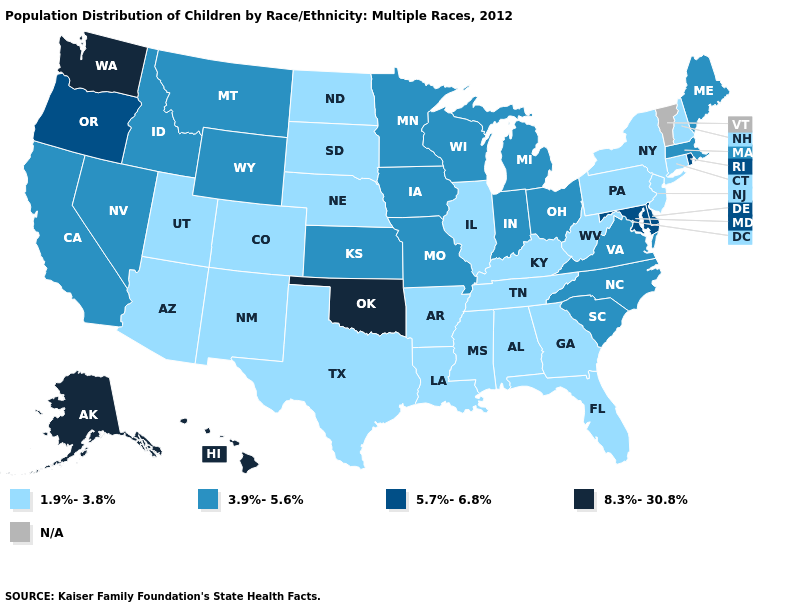What is the highest value in the West ?
Keep it brief. 8.3%-30.8%. Name the states that have a value in the range N/A?
Short answer required. Vermont. What is the value of Wisconsin?
Give a very brief answer. 3.9%-5.6%. Name the states that have a value in the range 3.9%-5.6%?
Keep it brief. California, Idaho, Indiana, Iowa, Kansas, Maine, Massachusetts, Michigan, Minnesota, Missouri, Montana, Nevada, North Carolina, Ohio, South Carolina, Virginia, Wisconsin, Wyoming. What is the highest value in the South ?
Give a very brief answer. 8.3%-30.8%. What is the lowest value in the South?
Be succinct. 1.9%-3.8%. Which states hav the highest value in the Northeast?
Give a very brief answer. Rhode Island. Does Montana have the highest value in the West?
Write a very short answer. No. Does Hawaii have the highest value in the USA?
Concise answer only. Yes. Among the states that border Arkansas , which have the highest value?
Concise answer only. Oklahoma. Name the states that have a value in the range N/A?
Short answer required. Vermont. Name the states that have a value in the range N/A?
Keep it brief. Vermont. Is the legend a continuous bar?
Give a very brief answer. No. 